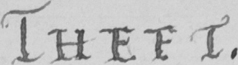Transcribe the text shown in this historical manuscript line. THEFT 